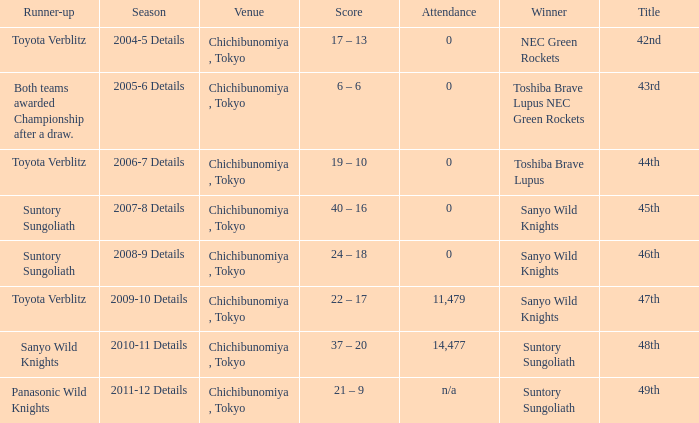What is the Attendance number when the runner-up was suntory sungoliath, and a Title of 46th? 0.0. 